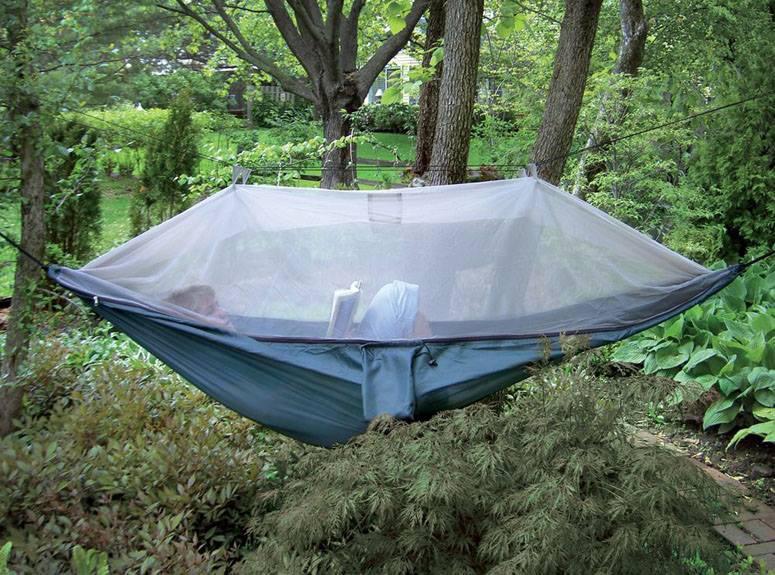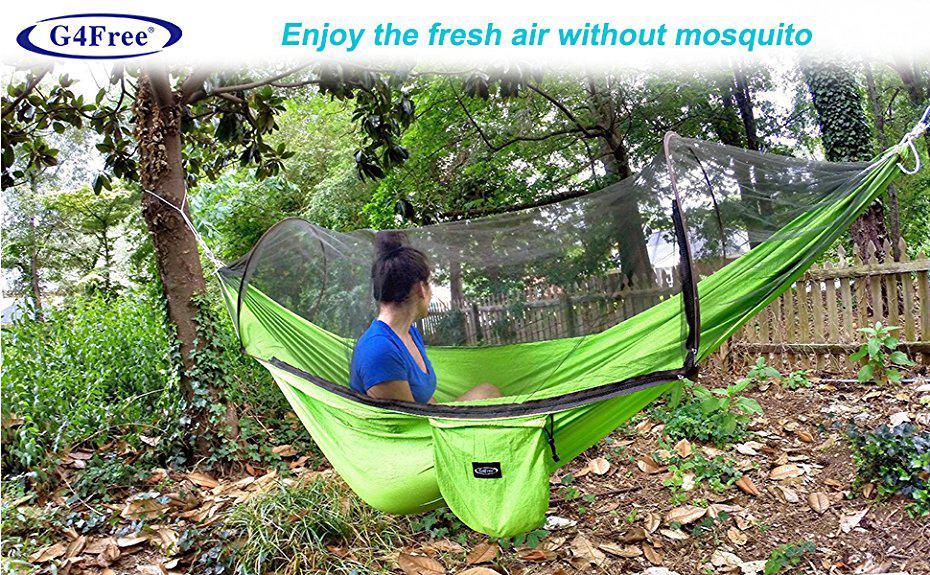The first image is the image on the left, the second image is the image on the right. Assess this claim about the two images: "A blue hammock hangs from a tree in one of the images.". Correct or not? Answer yes or no. Yes. The first image is the image on the left, the second image is the image on the right. For the images shown, is this caption "An image shows a hanging hammock that does not contain a person." true? Answer yes or no. No. 